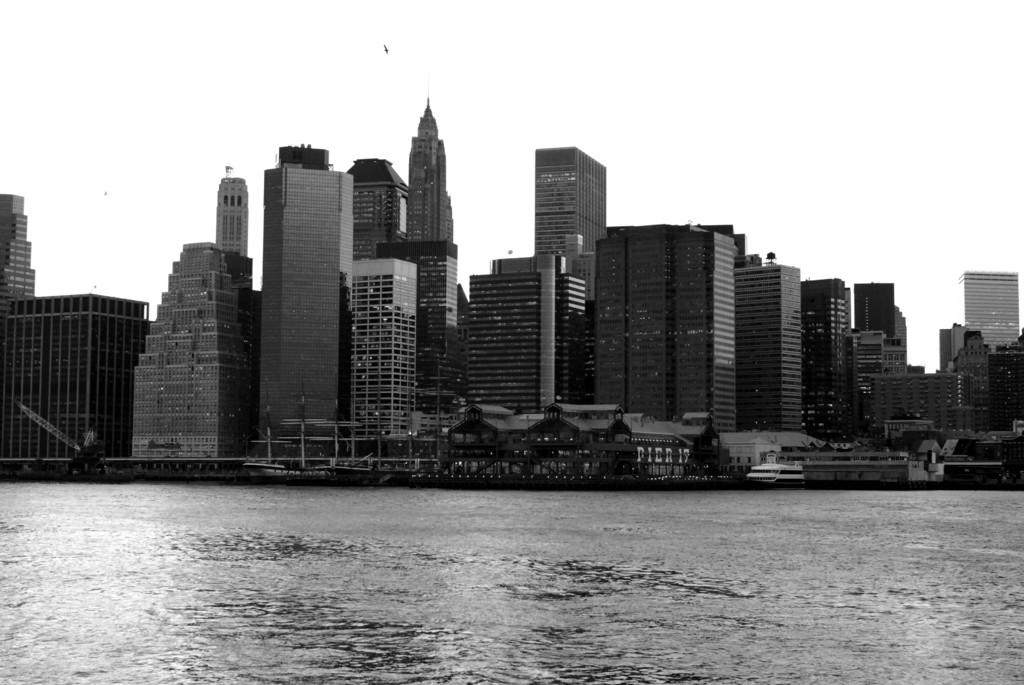What type of structures are present in the image? There are buildings in the image. What type of animals can be seen in the image? There are birds in the image. What type of illumination is visible in the image? There are lights in the image. What type of natural feature is present in the image? There is water in the image. What type of movement can be observed in the water? There are waves in the image. What part of the natural environment is visible in the image? The sky is visible in the image. What type of sound can be heard coming from the buildings in the image? There is no sound present in the image, as it is a visual representation and does not include audio. Are there any slaves depicted in the image? There is no reference to slavery or any slaves in the image. --- 